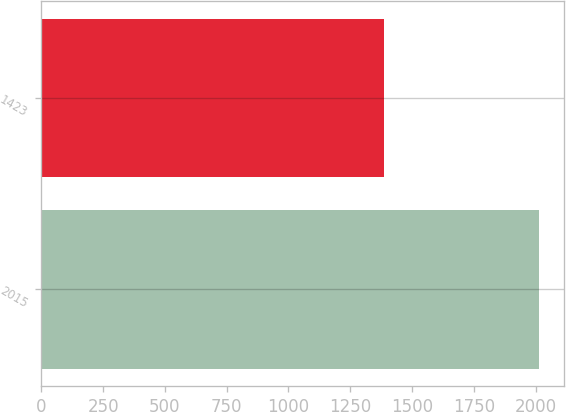Convert chart to OTSL. <chart><loc_0><loc_0><loc_500><loc_500><bar_chart><fcel>2015<fcel>1423<nl><fcel>2014<fcel>1387<nl></chart> 